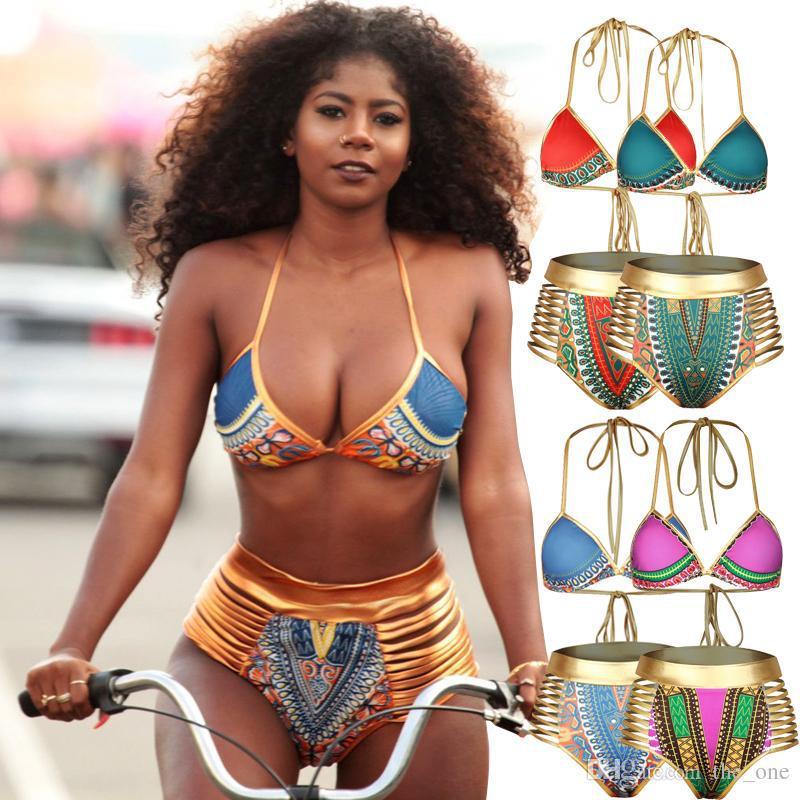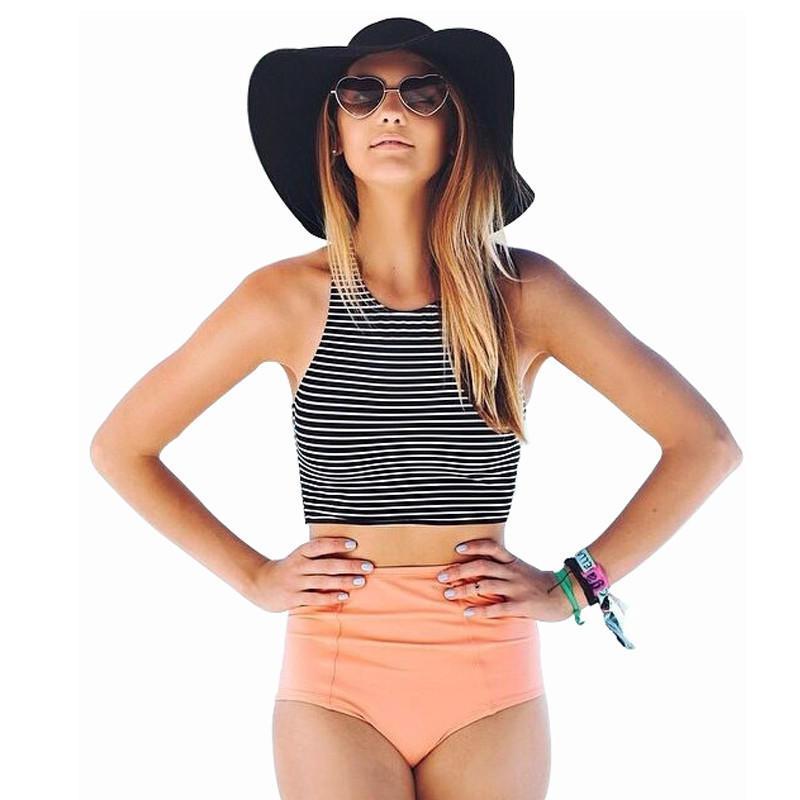The first image is the image on the left, the second image is the image on the right. Evaluate the accuracy of this statement regarding the images: "One of the models is wearing sunglasses.". Is it true? Answer yes or no. Yes. 